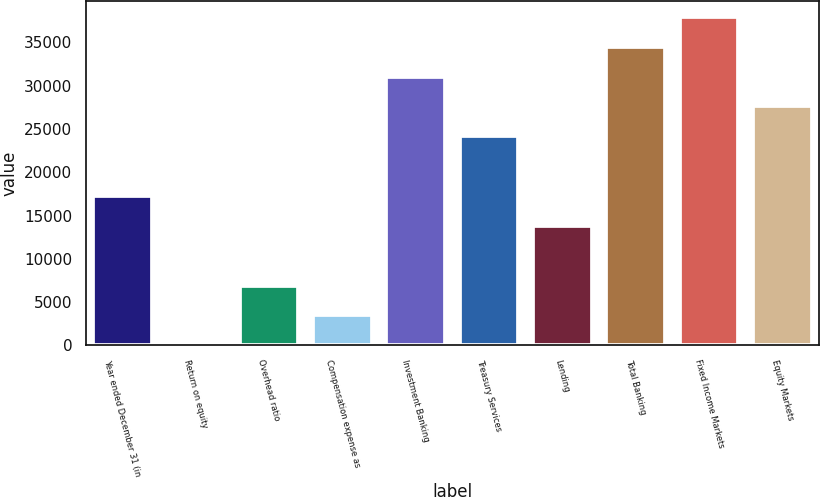Convert chart to OTSL. <chart><loc_0><loc_0><loc_500><loc_500><bar_chart><fcel>Year ended December 31 (in<fcel>Return on equity<fcel>Overhead ratio<fcel>Compensation expense as<fcel>Investment Banking<fcel>Treasury Services<fcel>Lending<fcel>Total Banking<fcel>Fixed Income Markets<fcel>Equity Markets<nl><fcel>17253.5<fcel>14<fcel>6909.8<fcel>3461.9<fcel>31045.1<fcel>24149.3<fcel>13805.6<fcel>34493<fcel>37940.9<fcel>27597.2<nl></chart> 